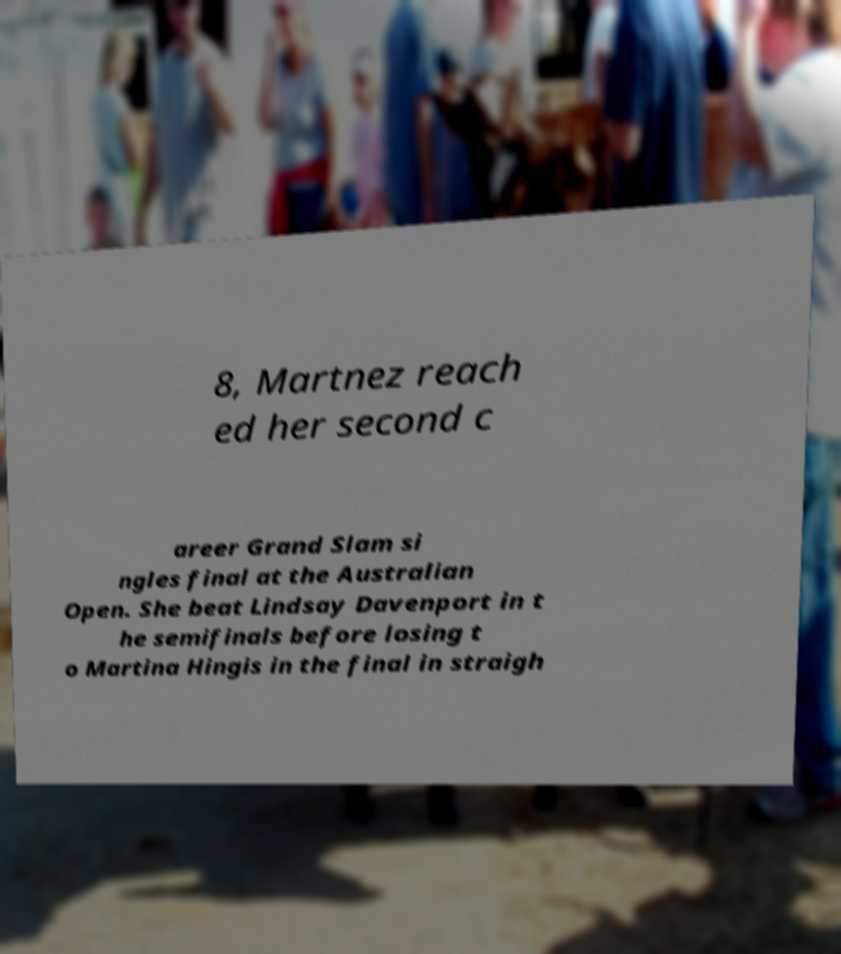Could you assist in decoding the text presented in this image and type it out clearly? 8, Martnez reach ed her second c areer Grand Slam si ngles final at the Australian Open. She beat Lindsay Davenport in t he semifinals before losing t o Martina Hingis in the final in straigh 